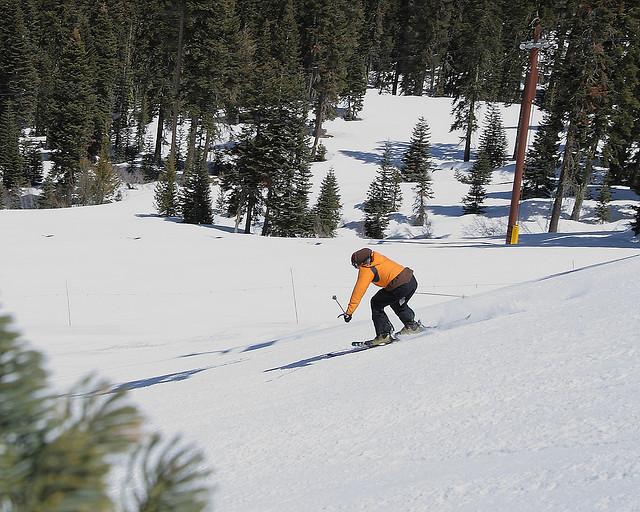What is the skier holding?
Give a very brief answer. Poles. Is it sunny outside?
Concise answer only. Yes. What color is his jacket?
Write a very short answer. Yellow. 